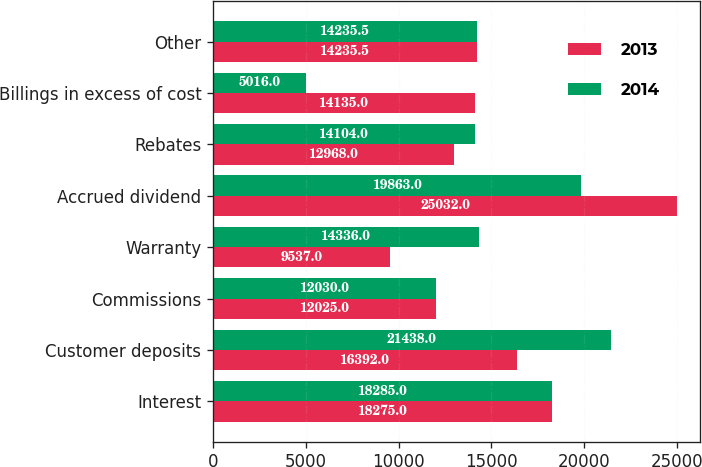<chart> <loc_0><loc_0><loc_500><loc_500><stacked_bar_chart><ecel><fcel>Interest<fcel>Customer deposits<fcel>Commissions<fcel>Warranty<fcel>Accrued dividend<fcel>Rebates<fcel>Billings in excess of cost<fcel>Other<nl><fcel>2013<fcel>18275<fcel>16392<fcel>12025<fcel>9537<fcel>25032<fcel>12968<fcel>14135<fcel>14235.5<nl><fcel>2014<fcel>18285<fcel>21438<fcel>12030<fcel>14336<fcel>19863<fcel>14104<fcel>5016<fcel>14235.5<nl></chart> 